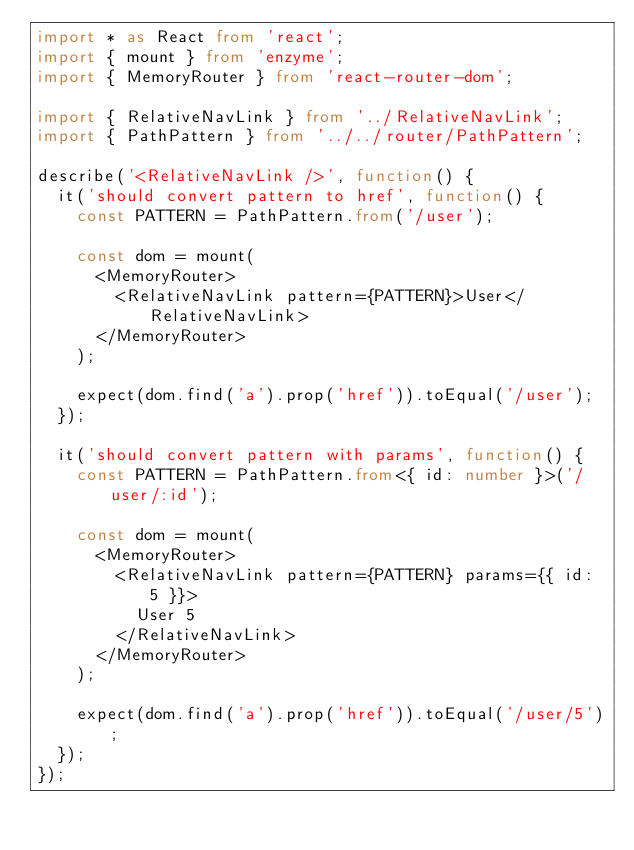<code> <loc_0><loc_0><loc_500><loc_500><_TypeScript_>import * as React from 'react';
import { mount } from 'enzyme';
import { MemoryRouter } from 'react-router-dom';

import { RelativeNavLink } from '../RelativeNavLink';
import { PathPattern } from '../../router/PathPattern';

describe('<RelativeNavLink />', function() {
  it('should convert pattern to href', function() {
    const PATTERN = PathPattern.from('/user');

    const dom = mount(
      <MemoryRouter>
        <RelativeNavLink pattern={PATTERN}>User</RelativeNavLink>
      </MemoryRouter>
    );

    expect(dom.find('a').prop('href')).toEqual('/user');
  });

  it('should convert pattern with params', function() {
    const PATTERN = PathPattern.from<{ id: number }>('/user/:id');

    const dom = mount(
      <MemoryRouter>
        <RelativeNavLink pattern={PATTERN} params={{ id: 5 }}>
          User 5
        </RelativeNavLink>
      </MemoryRouter>
    );

    expect(dom.find('a').prop('href')).toEqual('/user/5');
  });
});
</code> 